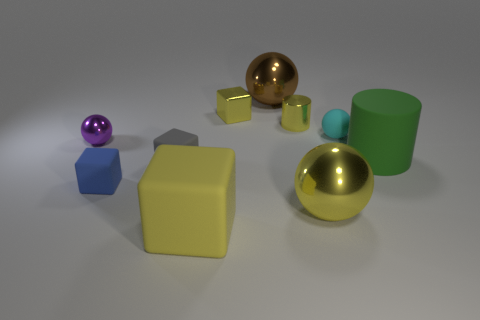Is there any other thing that has the same shape as the large yellow metal thing?
Make the answer very short. Yes. Is the small gray block made of the same material as the large brown object?
Your response must be concise. No. There is a large metallic sphere that is behind the green cylinder; are there any big things that are on the right side of it?
Your answer should be very brief. Yes. What number of objects are on the right side of the cyan thing and behind the metal cylinder?
Provide a succinct answer. 0. What shape is the large metallic object that is behind the green matte thing?
Keep it short and to the point. Sphere. What number of yellow matte things have the same size as the brown metal ball?
Make the answer very short. 1. Does the large sphere in front of the shiny cube have the same color as the large rubber block?
Your answer should be very brief. Yes. There is a big thing that is in front of the small metal cylinder and to the left of the tiny metallic cylinder; what material is it made of?
Provide a succinct answer. Rubber. Are there more large yellow cylinders than cyan objects?
Offer a terse response. No. What color is the rubber cube that is in front of the metallic ball in front of the thing that is to the left of the blue rubber block?
Give a very brief answer. Yellow. 